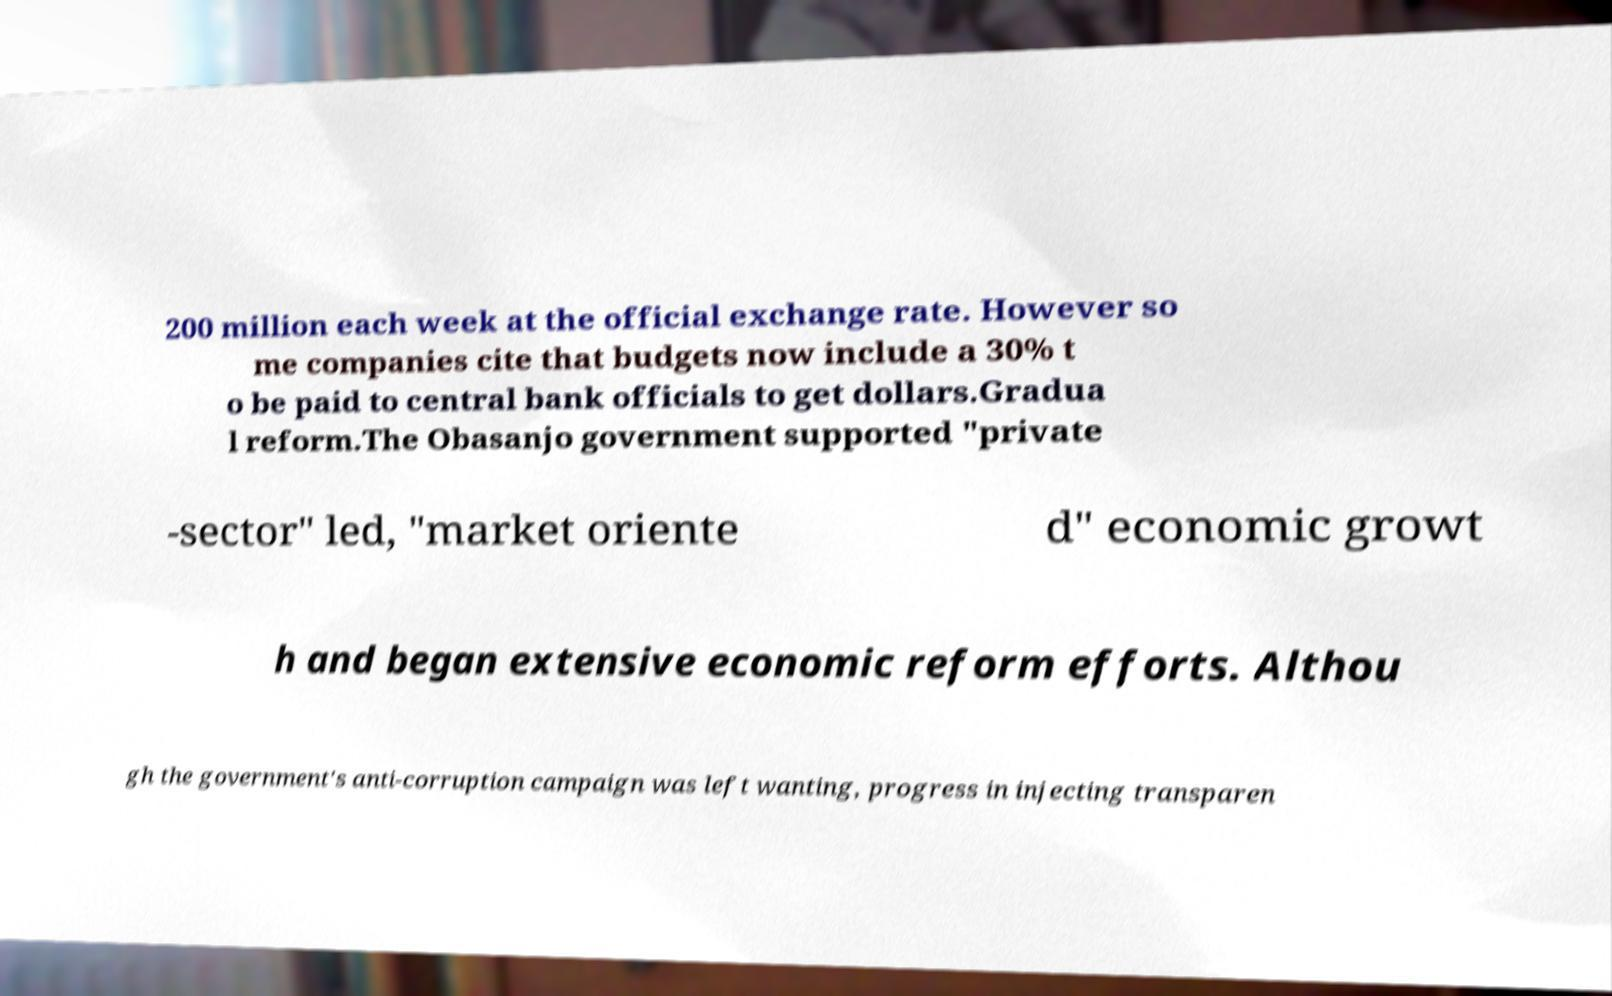Can you accurately transcribe the text from the provided image for me? 200 million each week at the official exchange rate. However so me companies cite that budgets now include a 30% t o be paid to central bank officials to get dollars.Gradua l reform.The Obasanjo government supported "private -sector" led, "market oriente d" economic growt h and began extensive economic reform efforts. Althou gh the government's anti-corruption campaign was left wanting, progress in injecting transparen 